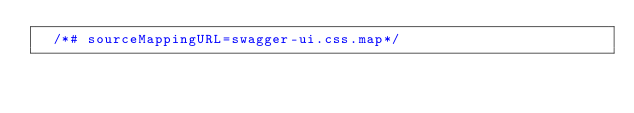Convert code to text. <code><loc_0><loc_0><loc_500><loc_500><_CSS_>  /*# sourceMappingURL=swagger-ui.css.map*/
</code> 